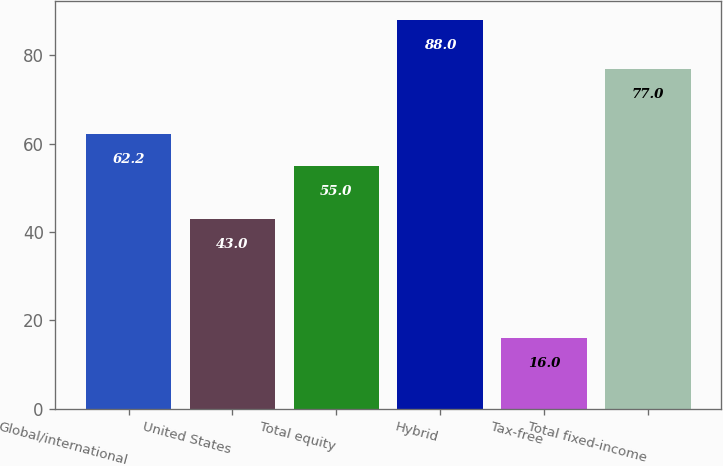Convert chart to OTSL. <chart><loc_0><loc_0><loc_500><loc_500><bar_chart><fcel>Global/international<fcel>United States<fcel>Total equity<fcel>Hybrid<fcel>Tax-free<fcel>Total fixed-income<nl><fcel>62.2<fcel>43<fcel>55<fcel>88<fcel>16<fcel>77<nl></chart> 